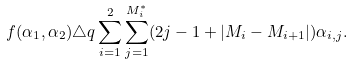<formula> <loc_0><loc_0><loc_500><loc_500>f ( \alpha _ { 1 } , \alpha _ { 2 } ) \triangle q \sum _ { i = 1 } ^ { 2 } \sum _ { j = 1 } ^ { M _ { i } ^ { * } } ( 2 j - 1 + | M _ { i } - M _ { i + 1 } | ) \alpha _ { i , j } .</formula> 